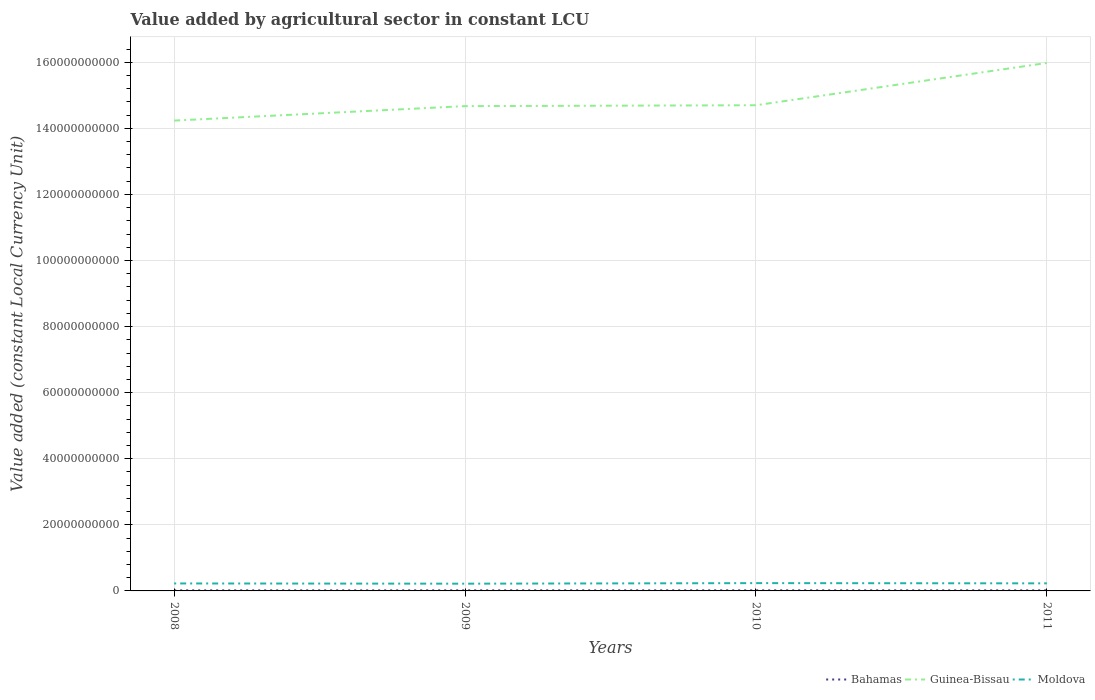How many different coloured lines are there?
Your answer should be compact. 3. Does the line corresponding to Bahamas intersect with the line corresponding to Moldova?
Make the answer very short. No. Across all years, what is the maximum value added by agricultural sector in Moldova?
Offer a very short reply. 2.19e+09. What is the total value added by agricultural sector in Moldova in the graph?
Keep it short and to the point. -1.69e+08. What is the difference between the highest and the second highest value added by agricultural sector in Guinea-Bissau?
Offer a very short reply. 1.74e+1. What is the difference between the highest and the lowest value added by agricultural sector in Moldova?
Give a very brief answer. 2. How many years are there in the graph?
Give a very brief answer. 4. What is the difference between two consecutive major ticks on the Y-axis?
Keep it short and to the point. 2.00e+1. Are the values on the major ticks of Y-axis written in scientific E-notation?
Your answer should be compact. No. Where does the legend appear in the graph?
Make the answer very short. Bottom right. How many legend labels are there?
Give a very brief answer. 3. How are the legend labels stacked?
Your answer should be very brief. Horizontal. What is the title of the graph?
Make the answer very short. Value added by agricultural sector in constant LCU. Does "Canada" appear as one of the legend labels in the graph?
Provide a short and direct response. No. What is the label or title of the Y-axis?
Provide a succinct answer. Value added (constant Local Currency Unit). What is the Value added (constant Local Currency Unit) in Bahamas in 2008?
Keep it short and to the point. 1.72e+08. What is the Value added (constant Local Currency Unit) of Guinea-Bissau in 2008?
Make the answer very short. 1.42e+11. What is the Value added (constant Local Currency Unit) of Moldova in 2008?
Provide a succinct answer. 2.26e+09. What is the Value added (constant Local Currency Unit) in Bahamas in 2009?
Keep it short and to the point. 1.79e+08. What is the Value added (constant Local Currency Unit) in Guinea-Bissau in 2009?
Your answer should be very brief. 1.47e+11. What is the Value added (constant Local Currency Unit) in Moldova in 2009?
Your answer should be very brief. 2.19e+09. What is the Value added (constant Local Currency Unit) of Bahamas in 2010?
Offer a terse response. 1.85e+08. What is the Value added (constant Local Currency Unit) in Guinea-Bissau in 2010?
Keep it short and to the point. 1.47e+11. What is the Value added (constant Local Currency Unit) in Moldova in 2010?
Provide a succinct answer. 2.36e+09. What is the Value added (constant Local Currency Unit) in Bahamas in 2011?
Give a very brief answer. 1.70e+08. What is the Value added (constant Local Currency Unit) in Guinea-Bissau in 2011?
Your answer should be very brief. 1.60e+11. What is the Value added (constant Local Currency Unit) in Moldova in 2011?
Your answer should be very brief. 2.29e+09. Across all years, what is the maximum Value added (constant Local Currency Unit) of Bahamas?
Your answer should be compact. 1.85e+08. Across all years, what is the maximum Value added (constant Local Currency Unit) of Guinea-Bissau?
Provide a short and direct response. 1.60e+11. Across all years, what is the maximum Value added (constant Local Currency Unit) of Moldova?
Offer a very short reply. 2.36e+09. Across all years, what is the minimum Value added (constant Local Currency Unit) of Bahamas?
Your answer should be compact. 1.70e+08. Across all years, what is the minimum Value added (constant Local Currency Unit) in Guinea-Bissau?
Make the answer very short. 1.42e+11. Across all years, what is the minimum Value added (constant Local Currency Unit) of Moldova?
Keep it short and to the point. 2.19e+09. What is the total Value added (constant Local Currency Unit) in Bahamas in the graph?
Provide a short and direct response. 7.06e+08. What is the total Value added (constant Local Currency Unit) of Guinea-Bissau in the graph?
Provide a short and direct response. 5.96e+11. What is the total Value added (constant Local Currency Unit) of Moldova in the graph?
Your answer should be compact. 9.11e+09. What is the difference between the Value added (constant Local Currency Unit) of Bahamas in 2008 and that in 2009?
Provide a succinct answer. -6.42e+06. What is the difference between the Value added (constant Local Currency Unit) of Guinea-Bissau in 2008 and that in 2009?
Offer a terse response. -4.38e+09. What is the difference between the Value added (constant Local Currency Unit) in Moldova in 2008 and that in 2009?
Provide a succinct answer. 7.00e+07. What is the difference between the Value added (constant Local Currency Unit) of Bahamas in 2008 and that in 2010?
Provide a short and direct response. -1.30e+07. What is the difference between the Value added (constant Local Currency Unit) of Guinea-Bissau in 2008 and that in 2010?
Offer a terse response. -4.64e+09. What is the difference between the Value added (constant Local Currency Unit) in Moldova in 2008 and that in 2010?
Your response must be concise. -9.90e+07. What is the difference between the Value added (constant Local Currency Unit) in Bahamas in 2008 and that in 2011?
Ensure brevity in your answer.  1.72e+06. What is the difference between the Value added (constant Local Currency Unit) in Guinea-Bissau in 2008 and that in 2011?
Ensure brevity in your answer.  -1.74e+1. What is the difference between the Value added (constant Local Currency Unit) in Moldova in 2008 and that in 2011?
Make the answer very short. -3.10e+07. What is the difference between the Value added (constant Local Currency Unit) in Bahamas in 2009 and that in 2010?
Your answer should be very brief. -6.56e+06. What is the difference between the Value added (constant Local Currency Unit) in Guinea-Bissau in 2009 and that in 2010?
Your answer should be compact. -2.68e+08. What is the difference between the Value added (constant Local Currency Unit) of Moldova in 2009 and that in 2010?
Your response must be concise. -1.69e+08. What is the difference between the Value added (constant Local Currency Unit) in Bahamas in 2009 and that in 2011?
Give a very brief answer. 8.13e+06. What is the difference between the Value added (constant Local Currency Unit) in Guinea-Bissau in 2009 and that in 2011?
Keep it short and to the point. -1.31e+1. What is the difference between the Value added (constant Local Currency Unit) of Moldova in 2009 and that in 2011?
Your response must be concise. -1.01e+08. What is the difference between the Value added (constant Local Currency Unit) in Bahamas in 2010 and that in 2011?
Your answer should be compact. 1.47e+07. What is the difference between the Value added (constant Local Currency Unit) of Guinea-Bissau in 2010 and that in 2011?
Offer a very short reply. -1.28e+1. What is the difference between the Value added (constant Local Currency Unit) in Moldova in 2010 and that in 2011?
Your answer should be very brief. 6.80e+07. What is the difference between the Value added (constant Local Currency Unit) of Bahamas in 2008 and the Value added (constant Local Currency Unit) of Guinea-Bissau in 2009?
Offer a very short reply. -1.47e+11. What is the difference between the Value added (constant Local Currency Unit) in Bahamas in 2008 and the Value added (constant Local Currency Unit) in Moldova in 2009?
Make the answer very short. -2.02e+09. What is the difference between the Value added (constant Local Currency Unit) in Guinea-Bissau in 2008 and the Value added (constant Local Currency Unit) in Moldova in 2009?
Provide a succinct answer. 1.40e+11. What is the difference between the Value added (constant Local Currency Unit) in Bahamas in 2008 and the Value added (constant Local Currency Unit) in Guinea-Bissau in 2010?
Give a very brief answer. -1.47e+11. What is the difference between the Value added (constant Local Currency Unit) of Bahamas in 2008 and the Value added (constant Local Currency Unit) of Moldova in 2010?
Ensure brevity in your answer.  -2.19e+09. What is the difference between the Value added (constant Local Currency Unit) of Guinea-Bissau in 2008 and the Value added (constant Local Currency Unit) of Moldova in 2010?
Provide a succinct answer. 1.40e+11. What is the difference between the Value added (constant Local Currency Unit) in Bahamas in 2008 and the Value added (constant Local Currency Unit) in Guinea-Bissau in 2011?
Offer a very short reply. -1.60e+11. What is the difference between the Value added (constant Local Currency Unit) in Bahamas in 2008 and the Value added (constant Local Currency Unit) in Moldova in 2011?
Give a very brief answer. -2.12e+09. What is the difference between the Value added (constant Local Currency Unit) of Guinea-Bissau in 2008 and the Value added (constant Local Currency Unit) of Moldova in 2011?
Your answer should be very brief. 1.40e+11. What is the difference between the Value added (constant Local Currency Unit) of Bahamas in 2009 and the Value added (constant Local Currency Unit) of Guinea-Bissau in 2010?
Make the answer very short. -1.47e+11. What is the difference between the Value added (constant Local Currency Unit) of Bahamas in 2009 and the Value added (constant Local Currency Unit) of Moldova in 2010?
Your answer should be compact. -2.18e+09. What is the difference between the Value added (constant Local Currency Unit) in Guinea-Bissau in 2009 and the Value added (constant Local Currency Unit) in Moldova in 2010?
Provide a succinct answer. 1.44e+11. What is the difference between the Value added (constant Local Currency Unit) of Bahamas in 2009 and the Value added (constant Local Currency Unit) of Guinea-Bissau in 2011?
Ensure brevity in your answer.  -1.60e+11. What is the difference between the Value added (constant Local Currency Unit) in Bahamas in 2009 and the Value added (constant Local Currency Unit) in Moldova in 2011?
Give a very brief answer. -2.11e+09. What is the difference between the Value added (constant Local Currency Unit) of Guinea-Bissau in 2009 and the Value added (constant Local Currency Unit) of Moldova in 2011?
Make the answer very short. 1.44e+11. What is the difference between the Value added (constant Local Currency Unit) of Bahamas in 2010 and the Value added (constant Local Currency Unit) of Guinea-Bissau in 2011?
Ensure brevity in your answer.  -1.60e+11. What is the difference between the Value added (constant Local Currency Unit) of Bahamas in 2010 and the Value added (constant Local Currency Unit) of Moldova in 2011?
Offer a terse response. -2.11e+09. What is the difference between the Value added (constant Local Currency Unit) in Guinea-Bissau in 2010 and the Value added (constant Local Currency Unit) in Moldova in 2011?
Offer a terse response. 1.45e+11. What is the average Value added (constant Local Currency Unit) of Bahamas per year?
Keep it short and to the point. 1.77e+08. What is the average Value added (constant Local Currency Unit) in Guinea-Bissau per year?
Ensure brevity in your answer.  1.49e+11. What is the average Value added (constant Local Currency Unit) in Moldova per year?
Provide a short and direct response. 2.28e+09. In the year 2008, what is the difference between the Value added (constant Local Currency Unit) in Bahamas and Value added (constant Local Currency Unit) in Guinea-Bissau?
Offer a very short reply. -1.42e+11. In the year 2008, what is the difference between the Value added (constant Local Currency Unit) of Bahamas and Value added (constant Local Currency Unit) of Moldova?
Make the answer very short. -2.09e+09. In the year 2008, what is the difference between the Value added (constant Local Currency Unit) in Guinea-Bissau and Value added (constant Local Currency Unit) in Moldova?
Provide a succinct answer. 1.40e+11. In the year 2009, what is the difference between the Value added (constant Local Currency Unit) in Bahamas and Value added (constant Local Currency Unit) in Guinea-Bissau?
Provide a succinct answer. -1.47e+11. In the year 2009, what is the difference between the Value added (constant Local Currency Unit) of Bahamas and Value added (constant Local Currency Unit) of Moldova?
Your response must be concise. -2.01e+09. In the year 2009, what is the difference between the Value added (constant Local Currency Unit) of Guinea-Bissau and Value added (constant Local Currency Unit) of Moldova?
Provide a succinct answer. 1.45e+11. In the year 2010, what is the difference between the Value added (constant Local Currency Unit) in Bahamas and Value added (constant Local Currency Unit) in Guinea-Bissau?
Your answer should be very brief. -1.47e+11. In the year 2010, what is the difference between the Value added (constant Local Currency Unit) of Bahamas and Value added (constant Local Currency Unit) of Moldova?
Your answer should be compact. -2.18e+09. In the year 2010, what is the difference between the Value added (constant Local Currency Unit) of Guinea-Bissau and Value added (constant Local Currency Unit) of Moldova?
Your answer should be very brief. 1.45e+11. In the year 2011, what is the difference between the Value added (constant Local Currency Unit) of Bahamas and Value added (constant Local Currency Unit) of Guinea-Bissau?
Make the answer very short. -1.60e+11. In the year 2011, what is the difference between the Value added (constant Local Currency Unit) of Bahamas and Value added (constant Local Currency Unit) of Moldova?
Your answer should be very brief. -2.12e+09. In the year 2011, what is the difference between the Value added (constant Local Currency Unit) in Guinea-Bissau and Value added (constant Local Currency Unit) in Moldova?
Your response must be concise. 1.57e+11. What is the ratio of the Value added (constant Local Currency Unit) in Bahamas in 2008 to that in 2009?
Make the answer very short. 0.96. What is the ratio of the Value added (constant Local Currency Unit) of Guinea-Bissau in 2008 to that in 2009?
Ensure brevity in your answer.  0.97. What is the ratio of the Value added (constant Local Currency Unit) in Moldova in 2008 to that in 2009?
Keep it short and to the point. 1.03. What is the ratio of the Value added (constant Local Currency Unit) in Bahamas in 2008 to that in 2010?
Offer a terse response. 0.93. What is the ratio of the Value added (constant Local Currency Unit) of Guinea-Bissau in 2008 to that in 2010?
Offer a very short reply. 0.97. What is the ratio of the Value added (constant Local Currency Unit) of Moldova in 2008 to that in 2010?
Give a very brief answer. 0.96. What is the ratio of the Value added (constant Local Currency Unit) in Bahamas in 2008 to that in 2011?
Give a very brief answer. 1.01. What is the ratio of the Value added (constant Local Currency Unit) of Guinea-Bissau in 2008 to that in 2011?
Your answer should be compact. 0.89. What is the ratio of the Value added (constant Local Currency Unit) in Moldova in 2008 to that in 2011?
Your response must be concise. 0.99. What is the ratio of the Value added (constant Local Currency Unit) in Bahamas in 2009 to that in 2010?
Provide a short and direct response. 0.96. What is the ratio of the Value added (constant Local Currency Unit) in Moldova in 2009 to that in 2010?
Offer a terse response. 0.93. What is the ratio of the Value added (constant Local Currency Unit) in Bahamas in 2009 to that in 2011?
Give a very brief answer. 1.05. What is the ratio of the Value added (constant Local Currency Unit) in Guinea-Bissau in 2009 to that in 2011?
Ensure brevity in your answer.  0.92. What is the ratio of the Value added (constant Local Currency Unit) in Moldova in 2009 to that in 2011?
Keep it short and to the point. 0.96. What is the ratio of the Value added (constant Local Currency Unit) of Bahamas in 2010 to that in 2011?
Ensure brevity in your answer.  1.09. What is the ratio of the Value added (constant Local Currency Unit) in Guinea-Bissau in 2010 to that in 2011?
Your response must be concise. 0.92. What is the ratio of the Value added (constant Local Currency Unit) in Moldova in 2010 to that in 2011?
Offer a very short reply. 1.03. What is the difference between the highest and the second highest Value added (constant Local Currency Unit) in Bahamas?
Keep it short and to the point. 6.56e+06. What is the difference between the highest and the second highest Value added (constant Local Currency Unit) in Guinea-Bissau?
Provide a succinct answer. 1.28e+1. What is the difference between the highest and the second highest Value added (constant Local Currency Unit) in Moldova?
Give a very brief answer. 6.80e+07. What is the difference between the highest and the lowest Value added (constant Local Currency Unit) of Bahamas?
Give a very brief answer. 1.47e+07. What is the difference between the highest and the lowest Value added (constant Local Currency Unit) in Guinea-Bissau?
Your answer should be very brief. 1.74e+1. What is the difference between the highest and the lowest Value added (constant Local Currency Unit) in Moldova?
Your response must be concise. 1.69e+08. 